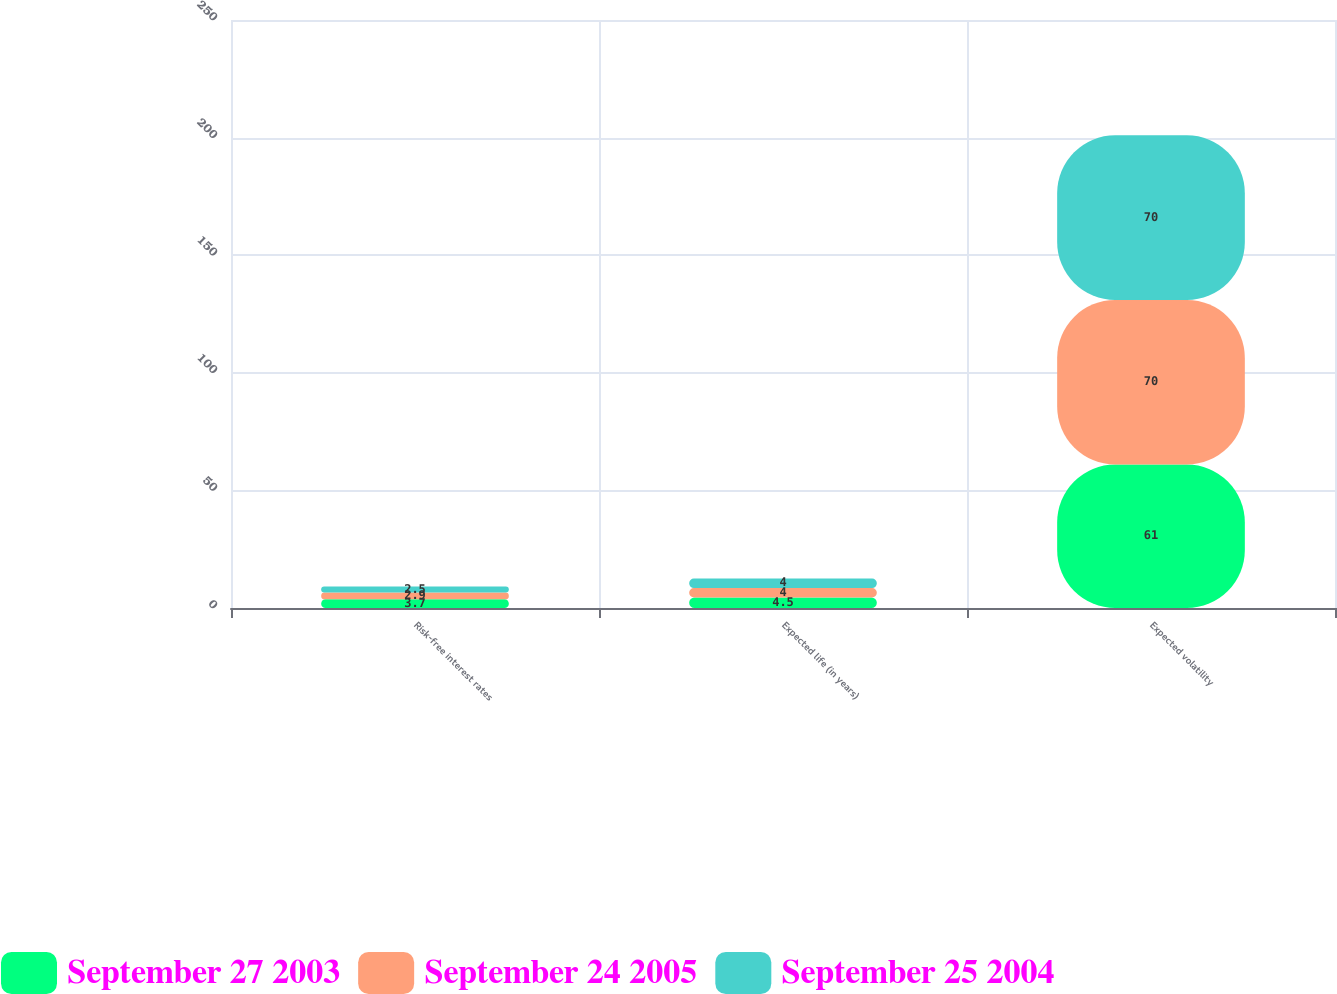<chart> <loc_0><loc_0><loc_500><loc_500><stacked_bar_chart><ecel><fcel>Risk-free interest rates<fcel>Expected life (in years)<fcel>Expected volatility<nl><fcel>September 27 2003<fcel>3.7<fcel>4.5<fcel>61<nl><fcel>September 24 2005<fcel>2.9<fcel>4<fcel>70<nl><fcel>September 25 2004<fcel>2.5<fcel>4<fcel>70<nl></chart> 